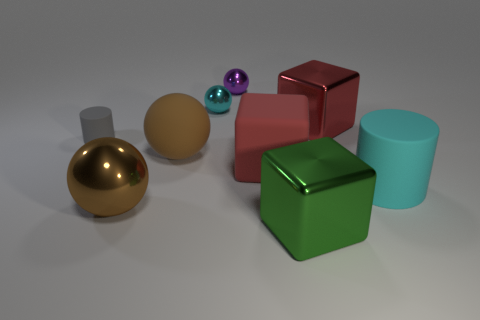The tiny purple thing that is made of the same material as the cyan sphere is what shape? sphere 